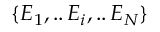<formula> <loc_0><loc_0><loc_500><loc_500>\{ E _ { 1 } , . . \, E _ { i } , . . \, E _ { N } \}</formula> 